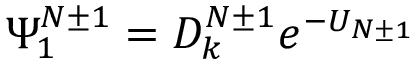<formula> <loc_0><loc_0><loc_500><loc_500>\Psi _ { 1 } ^ { N \pm 1 } = D _ { k } ^ { N \pm 1 } e ^ { - U _ { N \pm 1 } }</formula> 